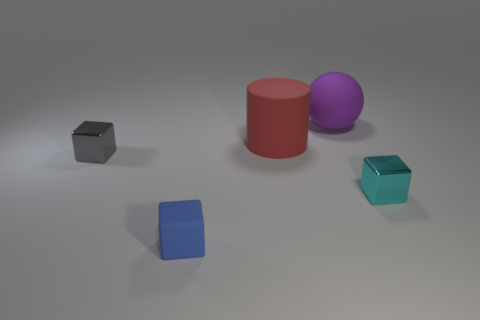Add 1 tiny purple rubber things. How many objects exist? 6 Subtract all cylinders. How many objects are left? 4 Subtract 1 blue blocks. How many objects are left? 4 Subtract all purple things. Subtract all red rubber things. How many objects are left? 3 Add 5 cyan objects. How many cyan objects are left? 6 Add 1 big purple things. How many big purple things exist? 2 